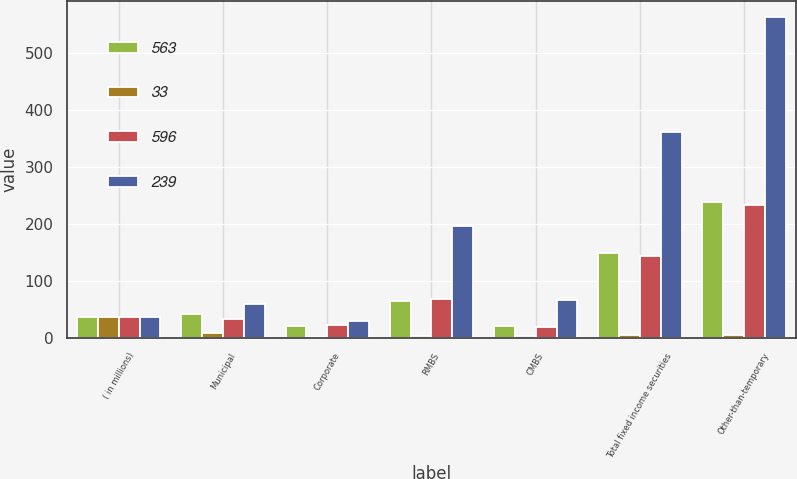Convert chart. <chart><loc_0><loc_0><loc_500><loc_500><stacked_bar_chart><ecel><fcel>( in millions)<fcel>Municipal<fcel>Corporate<fcel>RMBS<fcel>CMBS<fcel>Total fixed income securities<fcel>Other-than-temporary<nl><fcel>563<fcel>37.5<fcel>42<fcel>21<fcel>65<fcel>22<fcel>150<fcel>239<nl><fcel>33<fcel>37.5<fcel>9<fcel>2<fcel>4<fcel>3<fcel>6<fcel>6<nl><fcel>596<fcel>37.5<fcel>33<fcel>23<fcel>69<fcel>19<fcel>144<fcel>233<nl><fcel>239<fcel>37.5<fcel>59<fcel>30<fcel>196<fcel>66<fcel>361<fcel>563<nl></chart> 